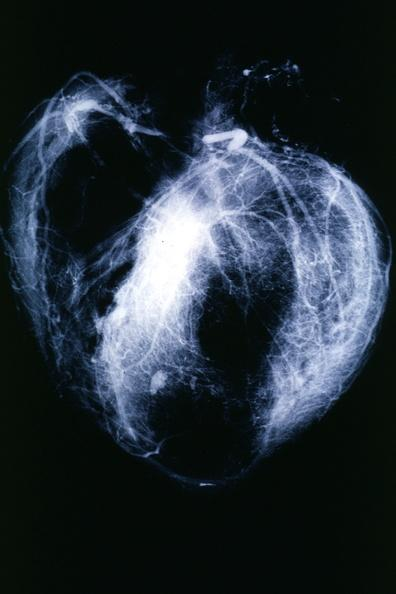how does this image show postmortangiogram?
Answer the question using a single word or phrase. With apparent lesions in proximal right coronary 